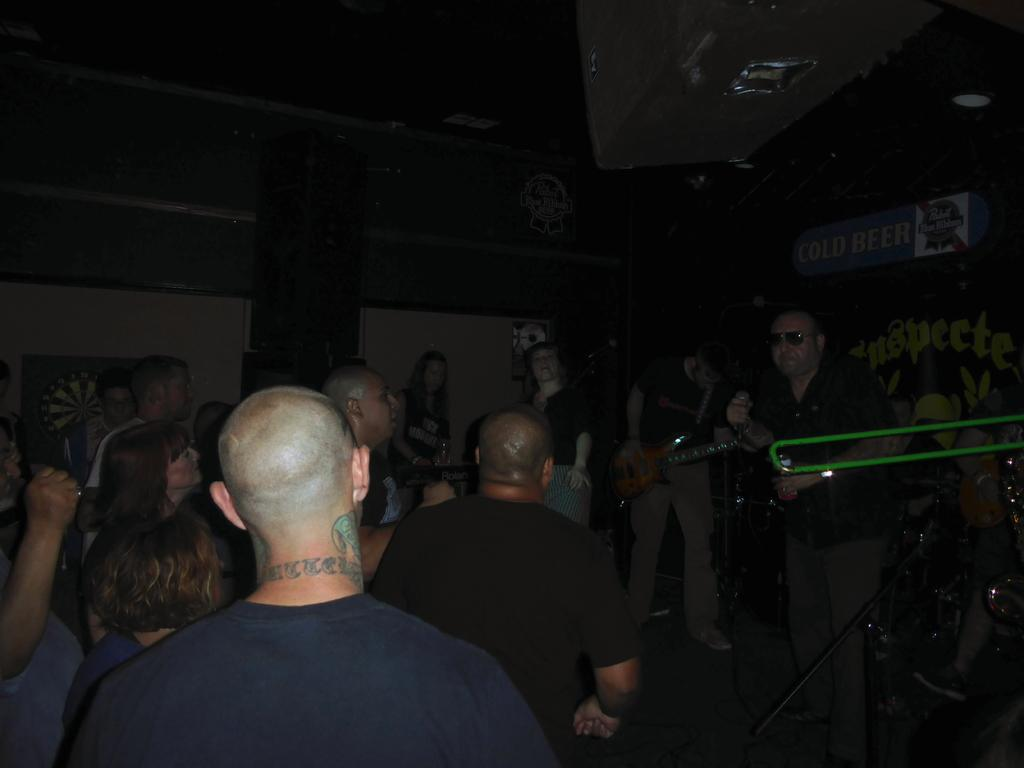How many people are in the image? There is a group of persons standing in the image. What is one of the men holding in the image? A man is holding a guitar in the image. What is another man holding in the image? A man is holding a microphone in the image. Can you describe the lighting in the image? The setting is dark. What type of class is being taught in the image? There is no class or teaching activity present in the image. What kind of doctor is visible in the image? There is no doctor present in the image. 